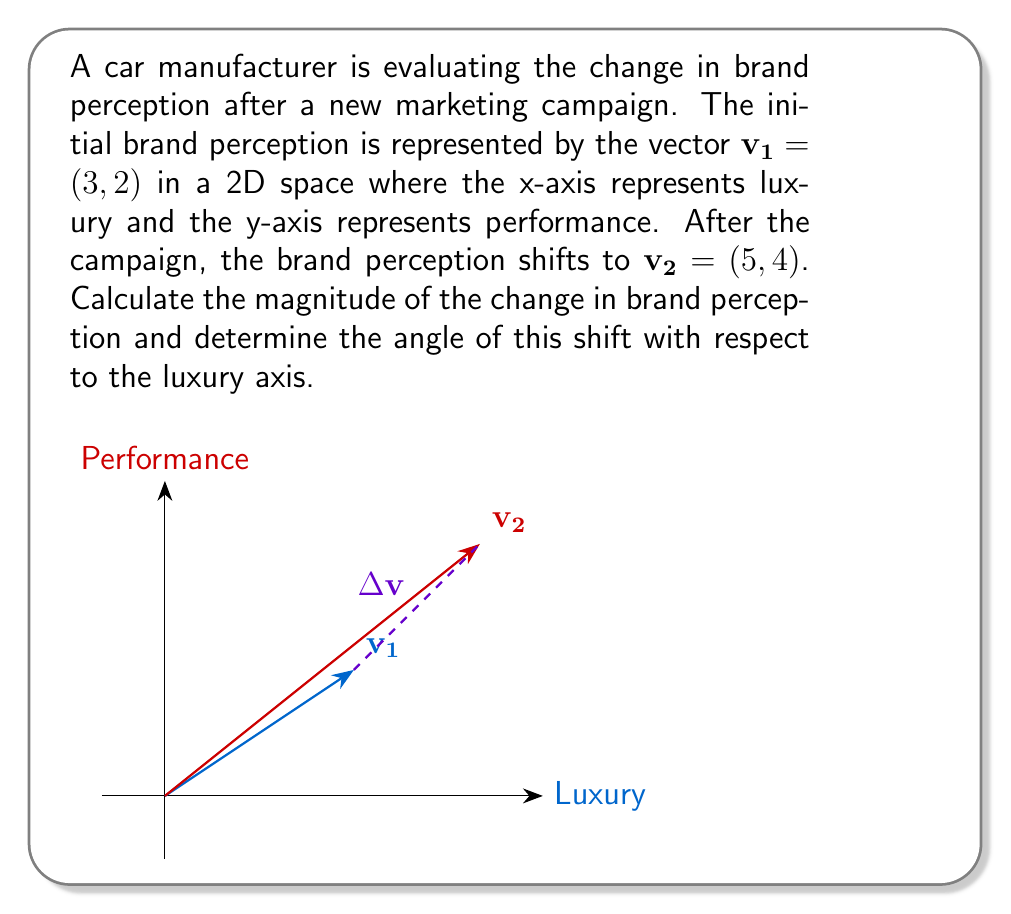Can you answer this question? To solve this problem, we'll follow these steps:

1) First, let's find the change vector $\Delta\mathbf{v}$:
   $$\Delta\mathbf{v} = \mathbf{v_2} - \mathbf{v_1} = (5,4) - (3,2) = (2,2)$$

2) The magnitude of the change is the length of $\Delta\mathbf{v}$:
   $$|\Delta\mathbf{v}| = \sqrt{2^2 + 2^2} = \sqrt{8} = 2\sqrt{2}$$

3) To find the angle of the shift with respect to the luxury axis, we can use the arctangent function:
   $$\theta = \arctan\left(\frac{y}{x}\right) = \arctan\left(\frac{2}{2}\right) = \arctan(1)$$

4) $\arctan(1)$ is equal to $\frac{\pi}{4}$ radians or 45 degrees.

Therefore, the magnitude of the change in brand perception is $2\sqrt{2}$ units, and the angle of the shift with respect to the luxury axis is 45 degrees.
Answer: Magnitude: $2\sqrt{2}$, Angle: 45° 